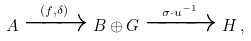<formula> <loc_0><loc_0><loc_500><loc_500>A \xrightarrow { ( f , \delta ) } B \oplus G \xrightarrow { \sigma \cdot u ^ { - 1 } } H \, ,</formula> 